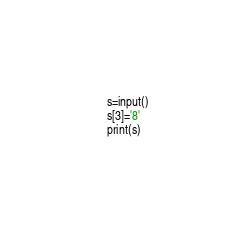<code> <loc_0><loc_0><loc_500><loc_500><_Python_>s=input()
s[3]='8'
print(s)</code> 